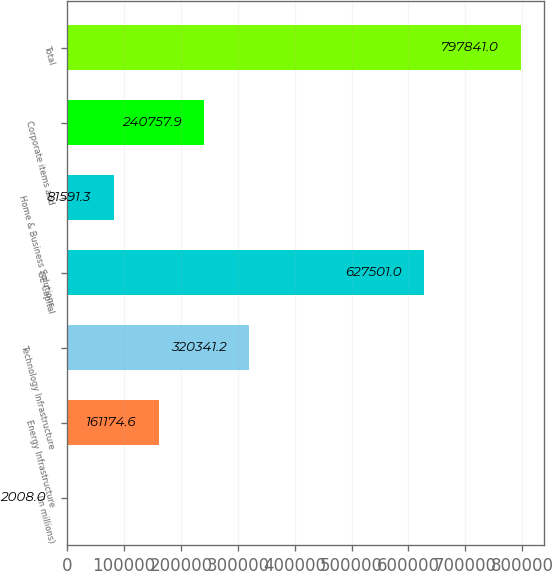Convert chart to OTSL. <chart><loc_0><loc_0><loc_500><loc_500><bar_chart><fcel>(In millions)<fcel>Energy Infrastructure<fcel>Technology Infrastructure<fcel>GE Capital<fcel>Home & Business Solutions<fcel>Corporate items and<fcel>Total<nl><fcel>2008<fcel>161175<fcel>320341<fcel>627501<fcel>81591.3<fcel>240758<fcel>797841<nl></chart> 